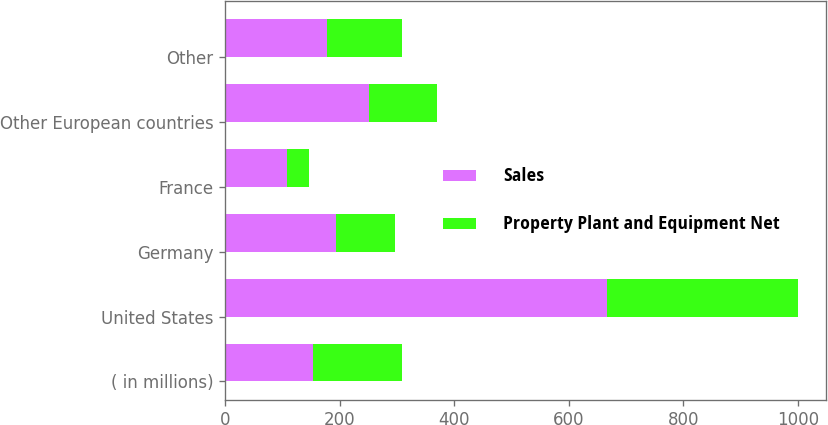Convert chart to OTSL. <chart><loc_0><loc_0><loc_500><loc_500><stacked_bar_chart><ecel><fcel>( in millions)<fcel>United States<fcel>Germany<fcel>France<fcel>Other European countries<fcel>Other<nl><fcel>Sales<fcel>154.2<fcel>667.4<fcel>194<fcel>107.6<fcel>252<fcel>178.8<nl><fcel>Property Plant and Equipment Net<fcel>154.2<fcel>332.3<fcel>102.9<fcel>38.6<fcel>117.6<fcel>129.6<nl></chart> 